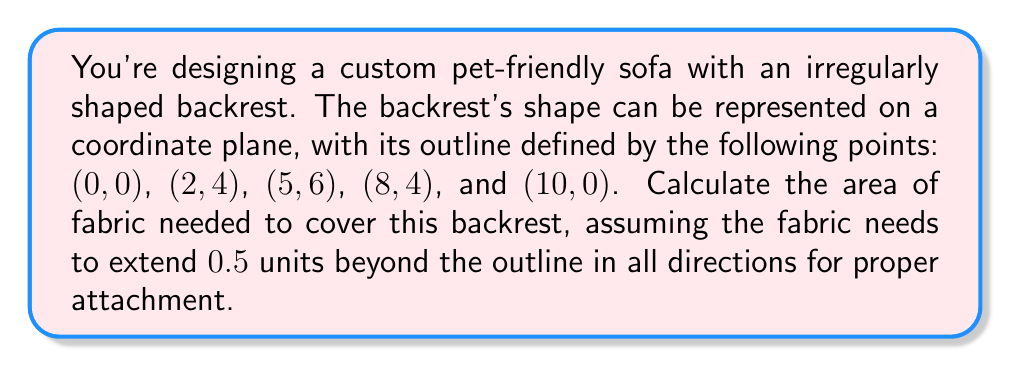Give your solution to this math problem. To solve this problem, we'll follow these steps:

1. Calculate the area of the original shape using the Shoelace formula.
2. Find the expanded shape by extending the original shape by 0.5 units in all directions.
3. Calculate the area of the expanded shape.

Step 1: Calculate the area of the original shape

The Shoelace formula for the area of a polygon with vertices $(x_1, y_1), (x_2, y_2), ..., (x_n, y_n)$ is:

$$ A = \frac{1}{2}|x_1y_2 + x_2y_3 + ... + x_ny_1 - y_1x_2 - y_2x_3 - ... - y_nx_1| $$

Applying this to our points:

$$ A = \frac{1}{2}|(0 \cdot 4 + 2 \cdot 6 + 5 \cdot 4 + 8 \cdot 0 + 10 \cdot 0) - (0 \cdot 2 + 4 \cdot 5 + 6 \cdot 8 + 4 \cdot 10 + 0 \cdot 0)| $$
$$ A = \frac{1}{2}|(0 + 12 + 20 + 0 + 0) - (0 + 20 + 48 + 40 + 0)| $$
$$ A = \frac{1}{2}|32 - 108| = \frac{1}{2} \cdot 76 = 38 \text{ square units} $$

Step 2: Find the expanded shape

To expand the shape, we need to move each point 0.5 units perpendicular to its adjacent sides. For the corner points, we'll move them diagonally. The new points are:

- (0,0) → (-0.5, -0.5)
- (2,4) → (1.5, 4.5)
- (5,6) → (5, 6.5)
- (8,4) → (8.5, 4.5)
- (10,0) → (10.5, -0.5)

Step 3: Calculate the area of the expanded shape

Using the Shoelace formula again with the new points:

$$ A_{expanded} = \frac{1}{2}|(-0.5 \cdot 4.5 + 1.5 \cdot 6.5 + 5 \cdot 4.5 + 8.5 \cdot (-0.5) + 10.5 \cdot (-0.5)) - $$
$$ (-0.5 \cdot 1.5 + 4.5 \cdot 5 + 6.5 \cdot 8.5 + 4.5 \cdot 10.5 + (-0.5) \cdot (-0.5))| $$

$$ A_{expanded} = \frac{1}{2}|(-2.25 + 9.75 + 22.5 - 4.25 - 5.25) - (-0.75 + 22.5 + 55.25 + 47.25 + 0.25)| $$
$$ A_{expanded} = \frac{1}{2}|20.5 - 124.5| = \frac{1}{2} \cdot 104 = 52 \text{ square units} $$

The area of fabric needed is the difference between the expanded area and the original area:

$$ A_{fabric} = A_{expanded} - A_{original} = 52 - 38 = 14 \text{ square units} $$
Answer: The area of fabric needed to cover the irregularly shaped backrest, extending 0.5 units beyond the outline, is 14 square units. 